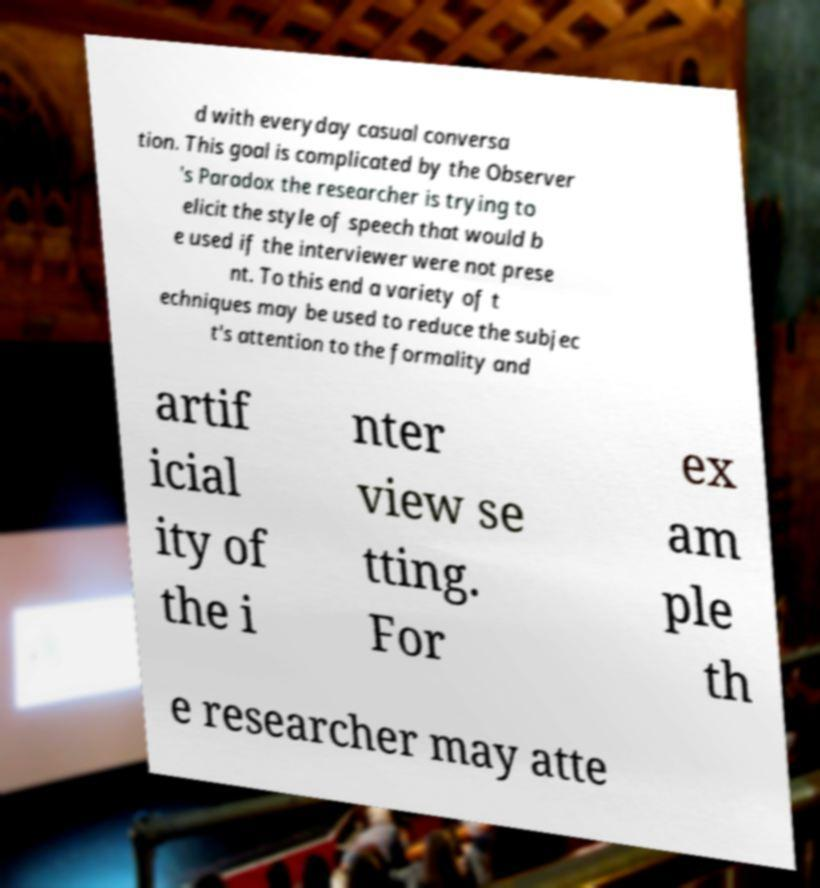For documentation purposes, I need the text within this image transcribed. Could you provide that? d with everyday casual conversa tion. This goal is complicated by the Observer 's Paradox the researcher is trying to elicit the style of speech that would b e used if the interviewer were not prese nt. To this end a variety of t echniques may be used to reduce the subjec t's attention to the formality and artif icial ity of the i nter view se tting. For ex am ple th e researcher may atte 